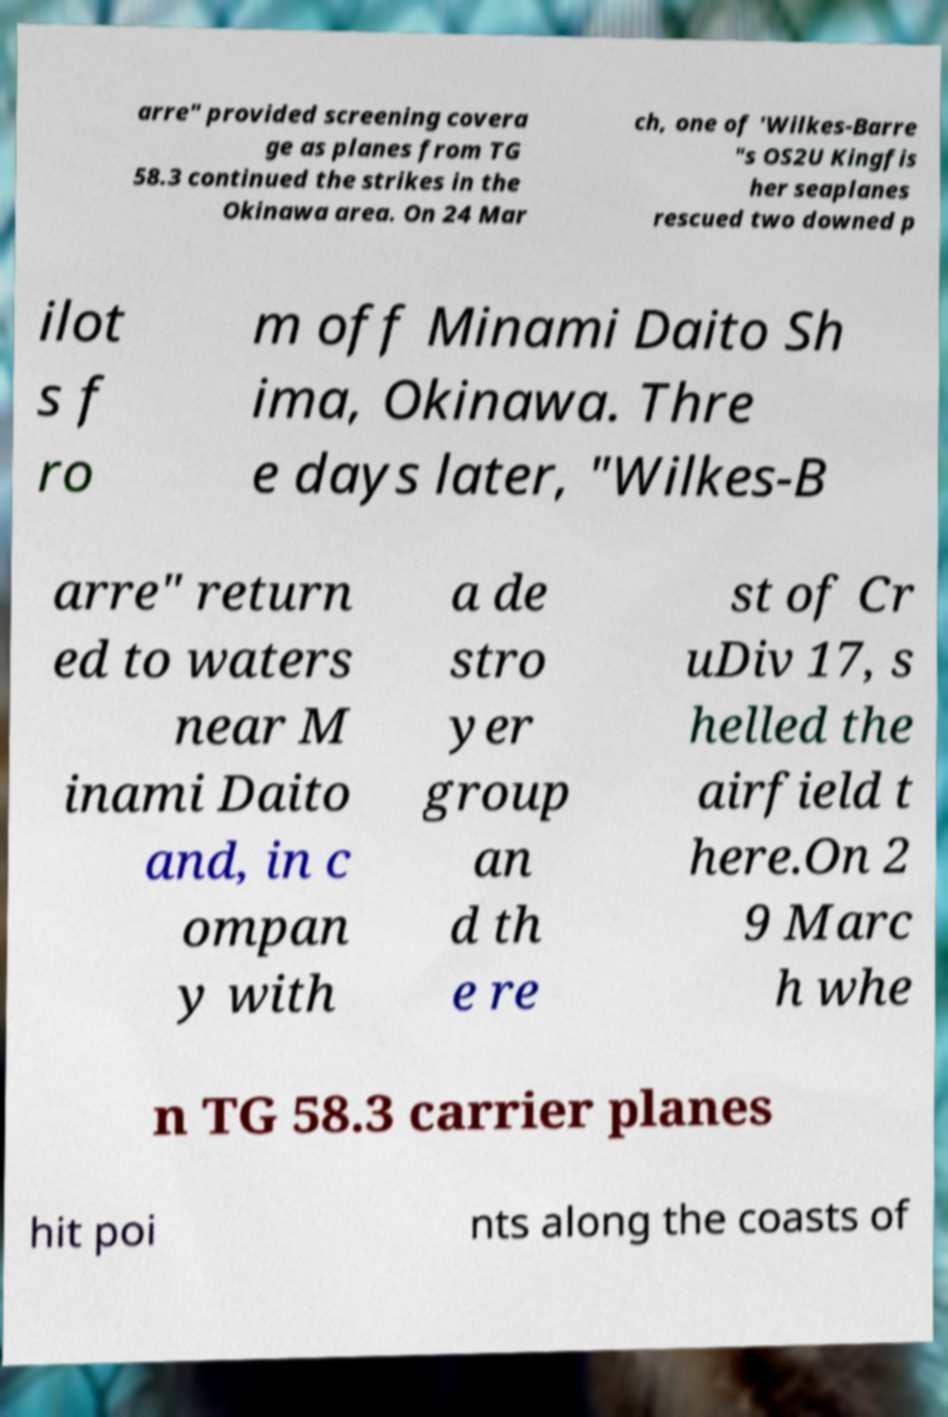What messages or text are displayed in this image? I need them in a readable, typed format. arre" provided screening covera ge as planes from TG 58.3 continued the strikes in the Okinawa area. On 24 Mar ch, one of 'Wilkes-Barre "s OS2U Kingfis her seaplanes rescued two downed p ilot s f ro m off Minami Daito Sh ima, Okinawa. Thre e days later, "Wilkes-B arre" return ed to waters near M inami Daito and, in c ompan y with a de stro yer group an d th e re st of Cr uDiv 17, s helled the airfield t here.On 2 9 Marc h whe n TG 58.3 carrier planes hit poi nts along the coasts of 